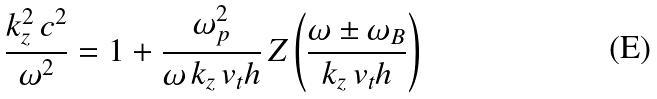<formula> <loc_0><loc_0><loc_500><loc_500>\frac { k _ { z } ^ { 2 } \, c ^ { 2 } } { \omega ^ { 2 } } = 1 + \frac { \omega _ { p } ^ { 2 } } { \omega \, k _ { z } \, v _ { t } h } \, Z \left ( \frac { \omega \pm \omega _ { B } } { k _ { z } \, v _ { t } h } \right )</formula> 